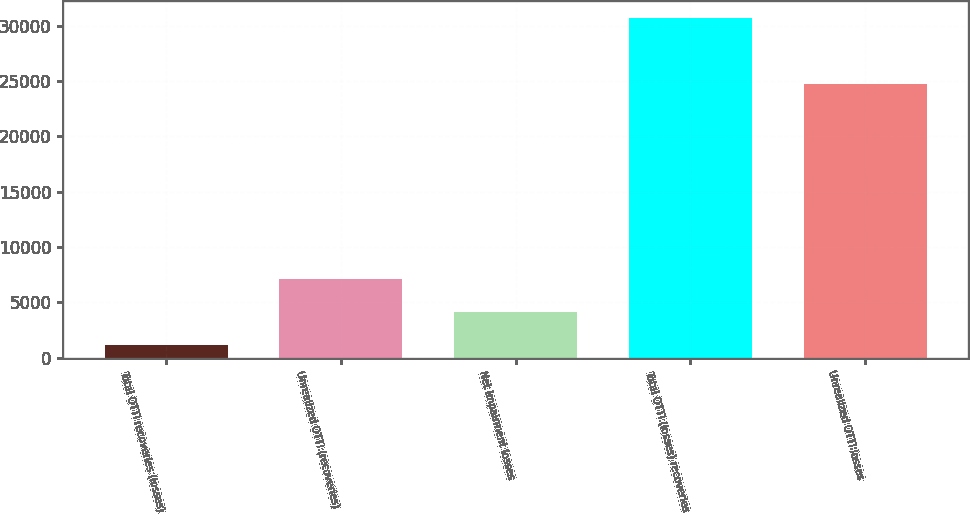Convert chart. <chart><loc_0><loc_0><loc_500><loc_500><bar_chart><fcel>Total OTTI recoveries (losses)<fcel>Unrealized OTTI (recoveries)<fcel>Net impairment losses<fcel>Total OTTI (losses) recoveries<fcel>Unrealized OTTI losses<nl><fcel>1163<fcel>7075.8<fcel>4119.4<fcel>30727<fcel>24731<nl></chart> 